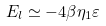<formula> <loc_0><loc_0><loc_500><loc_500>E _ { l } \simeq - 4 \beta \eta _ { 1 } \varepsilon \,</formula> 